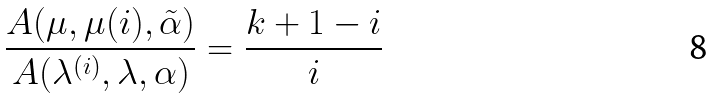Convert formula to latex. <formula><loc_0><loc_0><loc_500><loc_500>\frac { A ( \mu , \mu ( i ) , \tilde { \alpha } ) } { A ( \lambda ^ { ( i ) } , \lambda , \alpha ) } = \frac { k + 1 - i } { i }</formula> 